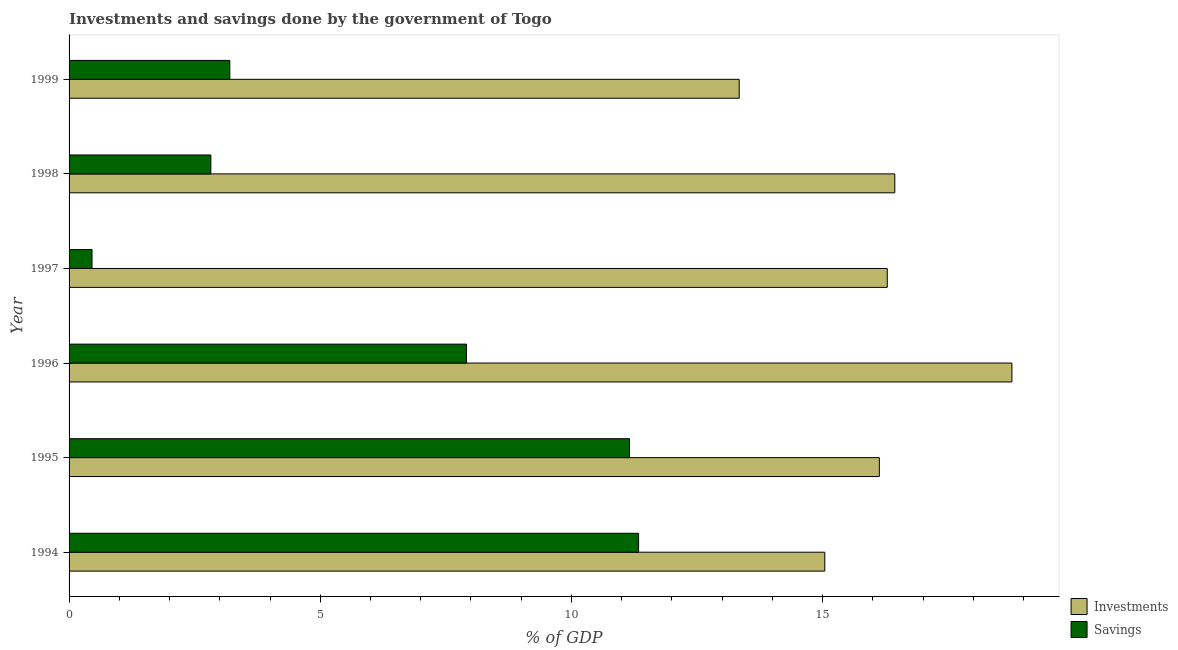How many different coloured bars are there?
Ensure brevity in your answer.  2. How many groups of bars are there?
Offer a terse response. 6. How many bars are there on the 1st tick from the top?
Provide a short and direct response. 2. How many bars are there on the 5th tick from the bottom?
Your answer should be very brief. 2. What is the investments of government in 1998?
Provide a succinct answer. 16.44. Across all years, what is the maximum savings of government?
Provide a succinct answer. 11.34. Across all years, what is the minimum savings of government?
Ensure brevity in your answer.  0.46. In which year was the investments of government maximum?
Your answer should be compact. 1996. In which year was the savings of government minimum?
Your response must be concise. 1997. What is the total investments of government in the graph?
Keep it short and to the point. 96.01. What is the difference between the savings of government in 1994 and that in 1999?
Provide a short and direct response. 8.14. What is the difference between the savings of government in 1994 and the investments of government in 1999?
Your answer should be compact. -2. What is the average investments of government per year?
Make the answer very short. 16. In the year 1996, what is the difference between the savings of government and investments of government?
Offer a terse response. -10.86. What is the ratio of the savings of government in 1998 to that in 1999?
Your answer should be compact. 0.88. Is the difference between the savings of government in 1994 and 1995 greater than the difference between the investments of government in 1994 and 1995?
Your answer should be very brief. Yes. What is the difference between the highest and the second highest investments of government?
Offer a very short reply. 2.33. What is the difference between the highest and the lowest savings of government?
Make the answer very short. 10.88. What does the 2nd bar from the top in 1996 represents?
Offer a very short reply. Investments. What does the 1st bar from the bottom in 1996 represents?
Give a very brief answer. Investments. Are all the bars in the graph horizontal?
Your answer should be very brief. Yes. What is the difference between two consecutive major ticks on the X-axis?
Your answer should be compact. 5. Where does the legend appear in the graph?
Ensure brevity in your answer.  Bottom right. How many legend labels are there?
Keep it short and to the point. 2. What is the title of the graph?
Ensure brevity in your answer.  Investments and savings done by the government of Togo. Does "Nonresident" appear as one of the legend labels in the graph?
Provide a short and direct response. No. What is the label or title of the X-axis?
Offer a terse response. % of GDP. What is the % of GDP in Investments in 1994?
Keep it short and to the point. 15.04. What is the % of GDP in Savings in 1994?
Offer a very short reply. 11.34. What is the % of GDP of Investments in 1995?
Give a very brief answer. 16.13. What is the % of GDP in Savings in 1995?
Offer a very short reply. 11.16. What is the % of GDP in Investments in 1996?
Keep it short and to the point. 18.77. What is the % of GDP in Savings in 1996?
Keep it short and to the point. 7.91. What is the % of GDP of Investments in 1997?
Keep it short and to the point. 16.29. What is the % of GDP of Savings in 1997?
Make the answer very short. 0.46. What is the % of GDP in Investments in 1998?
Offer a terse response. 16.44. What is the % of GDP in Savings in 1998?
Ensure brevity in your answer.  2.82. What is the % of GDP in Investments in 1999?
Offer a terse response. 13.34. What is the % of GDP of Savings in 1999?
Offer a very short reply. 3.2. Across all years, what is the maximum % of GDP in Investments?
Offer a terse response. 18.77. Across all years, what is the maximum % of GDP of Savings?
Provide a short and direct response. 11.34. Across all years, what is the minimum % of GDP of Investments?
Give a very brief answer. 13.34. Across all years, what is the minimum % of GDP of Savings?
Your response must be concise. 0.46. What is the total % of GDP of Investments in the graph?
Your response must be concise. 96.01. What is the total % of GDP of Savings in the graph?
Ensure brevity in your answer.  36.88. What is the difference between the % of GDP of Investments in 1994 and that in 1995?
Provide a succinct answer. -1.09. What is the difference between the % of GDP in Savings in 1994 and that in 1995?
Give a very brief answer. 0.18. What is the difference between the % of GDP in Investments in 1994 and that in 1996?
Provide a short and direct response. -3.73. What is the difference between the % of GDP of Savings in 1994 and that in 1996?
Offer a very short reply. 3.43. What is the difference between the % of GDP in Investments in 1994 and that in 1997?
Offer a terse response. -1.24. What is the difference between the % of GDP in Savings in 1994 and that in 1997?
Provide a succinct answer. 10.88. What is the difference between the % of GDP in Investments in 1994 and that in 1998?
Provide a short and direct response. -1.39. What is the difference between the % of GDP of Savings in 1994 and that in 1998?
Make the answer very short. 8.52. What is the difference between the % of GDP of Investments in 1994 and that in 1999?
Offer a very short reply. 1.7. What is the difference between the % of GDP of Savings in 1994 and that in 1999?
Your answer should be compact. 8.14. What is the difference between the % of GDP in Investments in 1995 and that in 1996?
Keep it short and to the point. -2.64. What is the difference between the % of GDP in Savings in 1995 and that in 1996?
Provide a short and direct response. 3.25. What is the difference between the % of GDP in Investments in 1995 and that in 1997?
Your response must be concise. -0.16. What is the difference between the % of GDP of Savings in 1995 and that in 1997?
Your answer should be compact. 10.7. What is the difference between the % of GDP in Investments in 1995 and that in 1998?
Your response must be concise. -0.31. What is the difference between the % of GDP in Savings in 1995 and that in 1998?
Keep it short and to the point. 8.34. What is the difference between the % of GDP in Investments in 1995 and that in 1999?
Offer a terse response. 2.79. What is the difference between the % of GDP of Savings in 1995 and that in 1999?
Your answer should be very brief. 7.96. What is the difference between the % of GDP in Investments in 1996 and that in 1997?
Keep it short and to the point. 2.48. What is the difference between the % of GDP in Savings in 1996 and that in 1997?
Your answer should be very brief. 7.45. What is the difference between the % of GDP in Investments in 1996 and that in 1998?
Provide a short and direct response. 2.33. What is the difference between the % of GDP in Savings in 1996 and that in 1998?
Make the answer very short. 5.09. What is the difference between the % of GDP of Investments in 1996 and that in 1999?
Give a very brief answer. 5.43. What is the difference between the % of GDP of Savings in 1996 and that in 1999?
Your answer should be compact. 4.71. What is the difference between the % of GDP of Investments in 1997 and that in 1998?
Your answer should be compact. -0.15. What is the difference between the % of GDP in Savings in 1997 and that in 1998?
Ensure brevity in your answer.  -2.37. What is the difference between the % of GDP in Investments in 1997 and that in 1999?
Your response must be concise. 2.95. What is the difference between the % of GDP in Savings in 1997 and that in 1999?
Offer a terse response. -2.74. What is the difference between the % of GDP in Investments in 1998 and that in 1999?
Provide a short and direct response. 3.1. What is the difference between the % of GDP of Savings in 1998 and that in 1999?
Your answer should be very brief. -0.38. What is the difference between the % of GDP in Investments in 1994 and the % of GDP in Savings in 1995?
Offer a very short reply. 3.89. What is the difference between the % of GDP of Investments in 1994 and the % of GDP of Savings in 1996?
Provide a short and direct response. 7.13. What is the difference between the % of GDP in Investments in 1994 and the % of GDP in Savings in 1997?
Provide a short and direct response. 14.59. What is the difference between the % of GDP of Investments in 1994 and the % of GDP of Savings in 1998?
Your answer should be compact. 12.22. What is the difference between the % of GDP in Investments in 1994 and the % of GDP in Savings in 1999?
Make the answer very short. 11.84. What is the difference between the % of GDP of Investments in 1995 and the % of GDP of Savings in 1996?
Make the answer very short. 8.22. What is the difference between the % of GDP in Investments in 1995 and the % of GDP in Savings in 1997?
Make the answer very short. 15.67. What is the difference between the % of GDP in Investments in 1995 and the % of GDP in Savings in 1998?
Your answer should be compact. 13.31. What is the difference between the % of GDP in Investments in 1995 and the % of GDP in Savings in 1999?
Offer a terse response. 12.93. What is the difference between the % of GDP in Investments in 1996 and the % of GDP in Savings in 1997?
Your answer should be very brief. 18.31. What is the difference between the % of GDP of Investments in 1996 and the % of GDP of Savings in 1998?
Offer a terse response. 15.95. What is the difference between the % of GDP in Investments in 1996 and the % of GDP in Savings in 1999?
Your answer should be compact. 15.57. What is the difference between the % of GDP in Investments in 1997 and the % of GDP in Savings in 1998?
Your response must be concise. 13.47. What is the difference between the % of GDP in Investments in 1997 and the % of GDP in Savings in 1999?
Keep it short and to the point. 13.09. What is the difference between the % of GDP of Investments in 1998 and the % of GDP of Savings in 1999?
Make the answer very short. 13.24. What is the average % of GDP of Investments per year?
Give a very brief answer. 16. What is the average % of GDP in Savings per year?
Provide a succinct answer. 6.15. In the year 1994, what is the difference between the % of GDP of Investments and % of GDP of Savings?
Your response must be concise. 3.71. In the year 1995, what is the difference between the % of GDP of Investments and % of GDP of Savings?
Offer a very short reply. 4.97. In the year 1996, what is the difference between the % of GDP of Investments and % of GDP of Savings?
Make the answer very short. 10.86. In the year 1997, what is the difference between the % of GDP of Investments and % of GDP of Savings?
Make the answer very short. 15.83. In the year 1998, what is the difference between the % of GDP in Investments and % of GDP in Savings?
Make the answer very short. 13.62. In the year 1999, what is the difference between the % of GDP of Investments and % of GDP of Savings?
Your answer should be very brief. 10.14. What is the ratio of the % of GDP of Investments in 1994 to that in 1995?
Offer a very short reply. 0.93. What is the ratio of the % of GDP of Savings in 1994 to that in 1995?
Provide a succinct answer. 1.02. What is the ratio of the % of GDP of Investments in 1994 to that in 1996?
Give a very brief answer. 0.8. What is the ratio of the % of GDP in Savings in 1994 to that in 1996?
Keep it short and to the point. 1.43. What is the ratio of the % of GDP of Investments in 1994 to that in 1997?
Make the answer very short. 0.92. What is the ratio of the % of GDP in Savings in 1994 to that in 1997?
Provide a succinct answer. 24.81. What is the ratio of the % of GDP of Investments in 1994 to that in 1998?
Provide a short and direct response. 0.92. What is the ratio of the % of GDP of Savings in 1994 to that in 1998?
Ensure brevity in your answer.  4.02. What is the ratio of the % of GDP of Investments in 1994 to that in 1999?
Give a very brief answer. 1.13. What is the ratio of the % of GDP in Savings in 1994 to that in 1999?
Your response must be concise. 3.54. What is the ratio of the % of GDP of Investments in 1995 to that in 1996?
Make the answer very short. 0.86. What is the ratio of the % of GDP of Savings in 1995 to that in 1996?
Your response must be concise. 1.41. What is the ratio of the % of GDP of Investments in 1995 to that in 1997?
Provide a succinct answer. 0.99. What is the ratio of the % of GDP of Savings in 1995 to that in 1997?
Offer a very short reply. 24.42. What is the ratio of the % of GDP in Investments in 1995 to that in 1998?
Make the answer very short. 0.98. What is the ratio of the % of GDP of Savings in 1995 to that in 1998?
Keep it short and to the point. 3.95. What is the ratio of the % of GDP in Investments in 1995 to that in 1999?
Provide a short and direct response. 1.21. What is the ratio of the % of GDP of Savings in 1995 to that in 1999?
Give a very brief answer. 3.49. What is the ratio of the % of GDP in Investments in 1996 to that in 1997?
Your answer should be compact. 1.15. What is the ratio of the % of GDP in Savings in 1996 to that in 1997?
Provide a short and direct response. 17.31. What is the ratio of the % of GDP of Investments in 1996 to that in 1998?
Offer a terse response. 1.14. What is the ratio of the % of GDP of Savings in 1996 to that in 1998?
Your response must be concise. 2.8. What is the ratio of the % of GDP of Investments in 1996 to that in 1999?
Offer a terse response. 1.41. What is the ratio of the % of GDP in Savings in 1996 to that in 1999?
Your answer should be compact. 2.47. What is the ratio of the % of GDP in Investments in 1997 to that in 1998?
Your response must be concise. 0.99. What is the ratio of the % of GDP in Savings in 1997 to that in 1998?
Provide a succinct answer. 0.16. What is the ratio of the % of GDP in Investments in 1997 to that in 1999?
Make the answer very short. 1.22. What is the ratio of the % of GDP in Savings in 1997 to that in 1999?
Your response must be concise. 0.14. What is the ratio of the % of GDP in Investments in 1998 to that in 1999?
Offer a terse response. 1.23. What is the ratio of the % of GDP of Savings in 1998 to that in 1999?
Make the answer very short. 0.88. What is the difference between the highest and the second highest % of GDP in Investments?
Provide a short and direct response. 2.33. What is the difference between the highest and the second highest % of GDP in Savings?
Your response must be concise. 0.18. What is the difference between the highest and the lowest % of GDP of Investments?
Ensure brevity in your answer.  5.43. What is the difference between the highest and the lowest % of GDP in Savings?
Give a very brief answer. 10.88. 